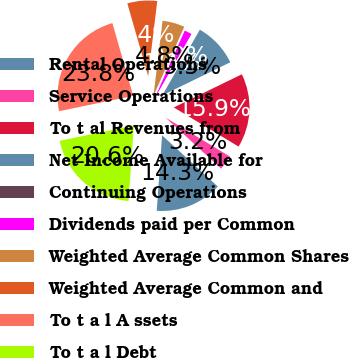<chart> <loc_0><loc_0><loc_500><loc_500><pie_chart><fcel>Rental Operations<fcel>Service Operations<fcel>To t al Revenues from<fcel>Net Income Available for<fcel>Continuing Operations<fcel>Dividends paid per Common<fcel>Weighted Average Common Shares<fcel>Weighted Average Common and<fcel>To t a l A ssets<fcel>To t a l Debt<nl><fcel>14.29%<fcel>3.17%<fcel>15.87%<fcel>9.52%<fcel>0.0%<fcel>1.59%<fcel>4.76%<fcel>6.35%<fcel>23.81%<fcel>20.63%<nl></chart> 